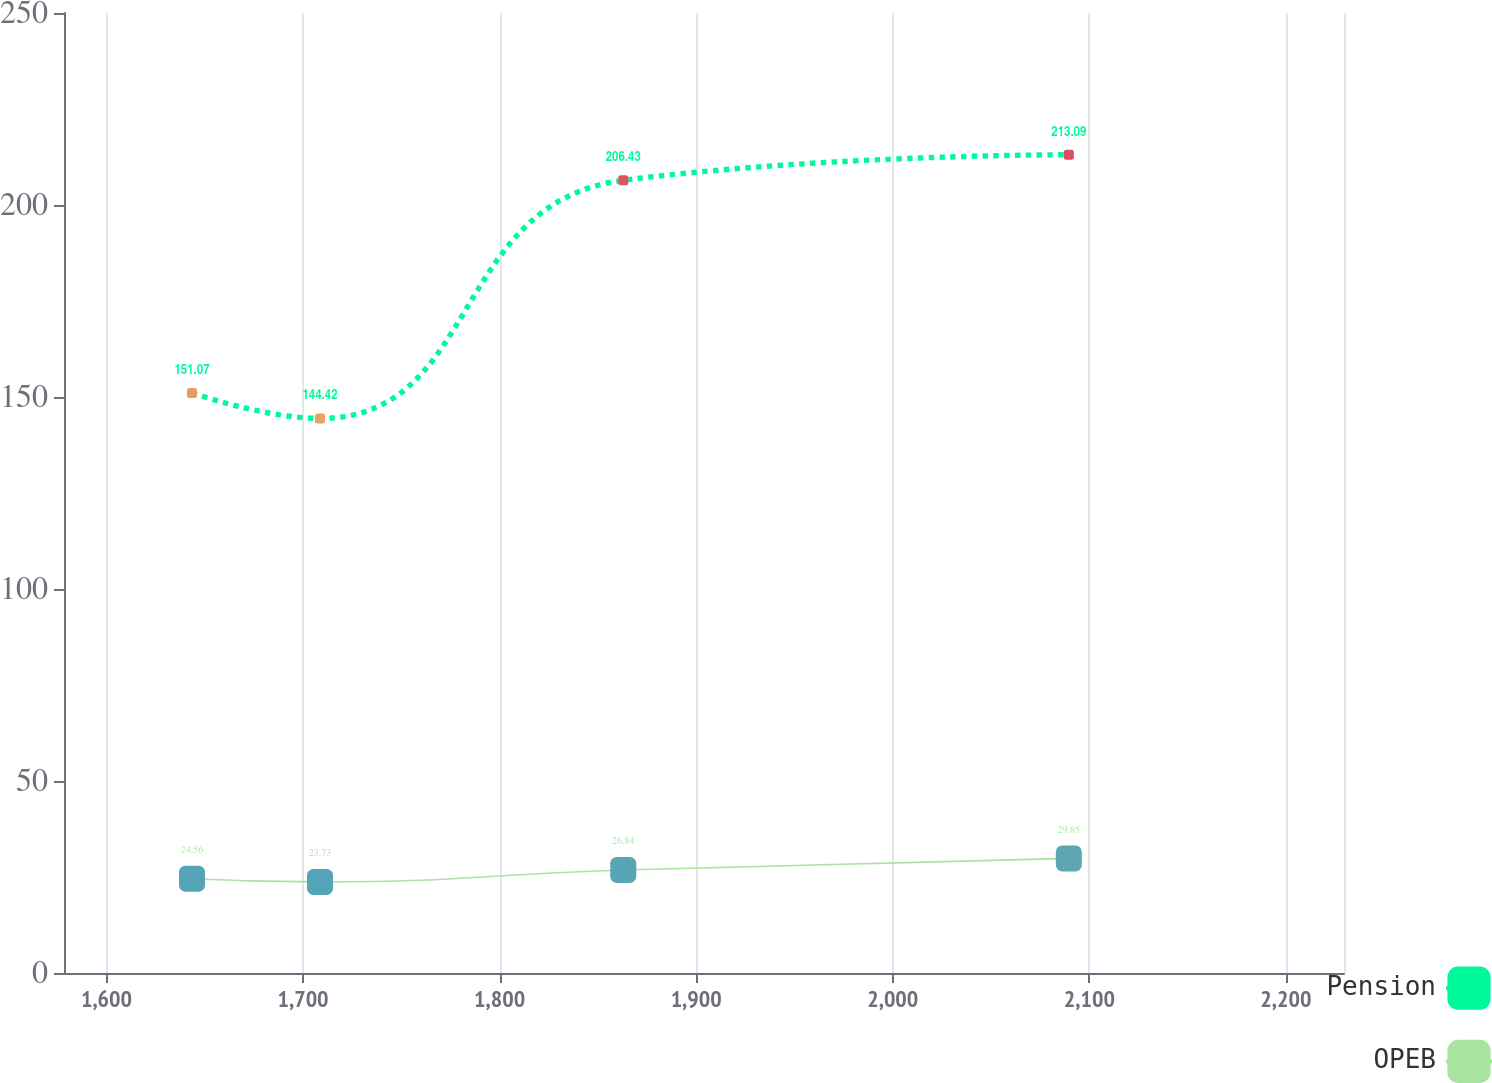Convert chart. <chart><loc_0><loc_0><loc_500><loc_500><line_chart><ecel><fcel>Pension<fcel>OPEB<nl><fcel>1643.51<fcel>151.07<fcel>24.56<nl><fcel>1708.63<fcel>144.42<fcel>23.73<nl><fcel>1862.9<fcel>206.43<fcel>26.84<nl><fcel>2089.57<fcel>213.09<fcel>29.85<nl><fcel>2294.67<fcel>170.27<fcel>21.58<nl></chart> 